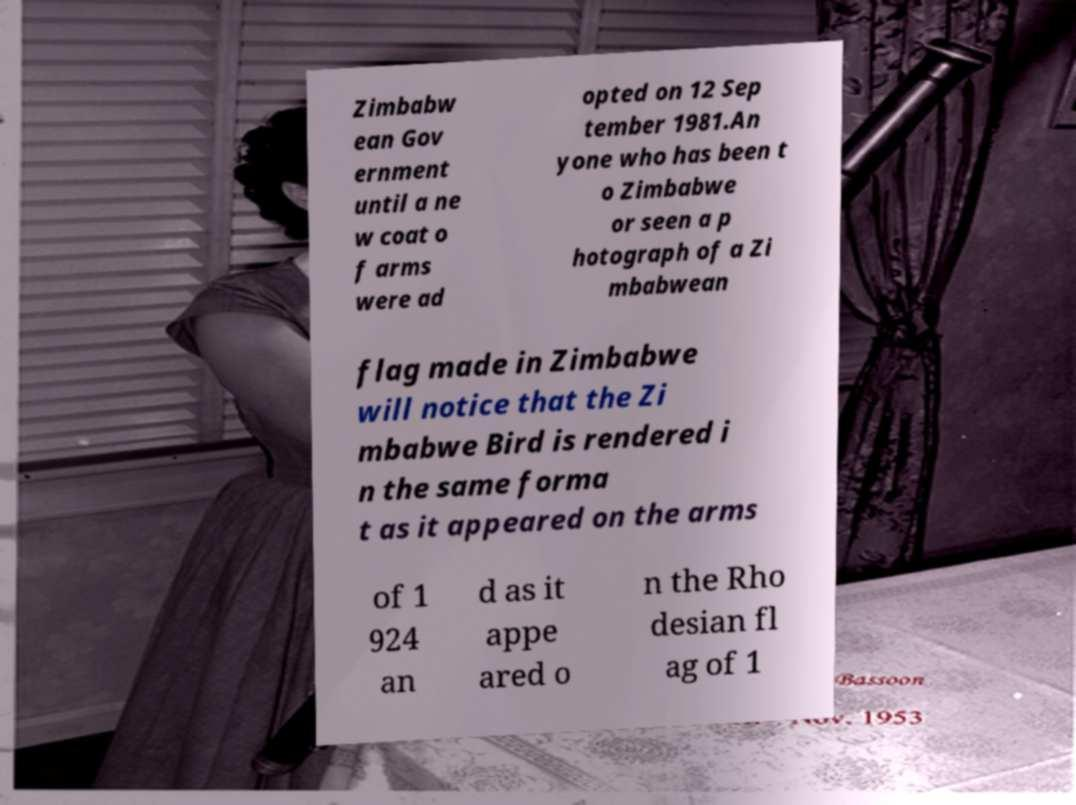Please identify and transcribe the text found in this image. Zimbabw ean Gov ernment until a ne w coat o f arms were ad opted on 12 Sep tember 1981.An yone who has been t o Zimbabwe or seen a p hotograph of a Zi mbabwean flag made in Zimbabwe will notice that the Zi mbabwe Bird is rendered i n the same forma t as it appeared on the arms of 1 924 an d as it appe ared o n the Rho desian fl ag of 1 